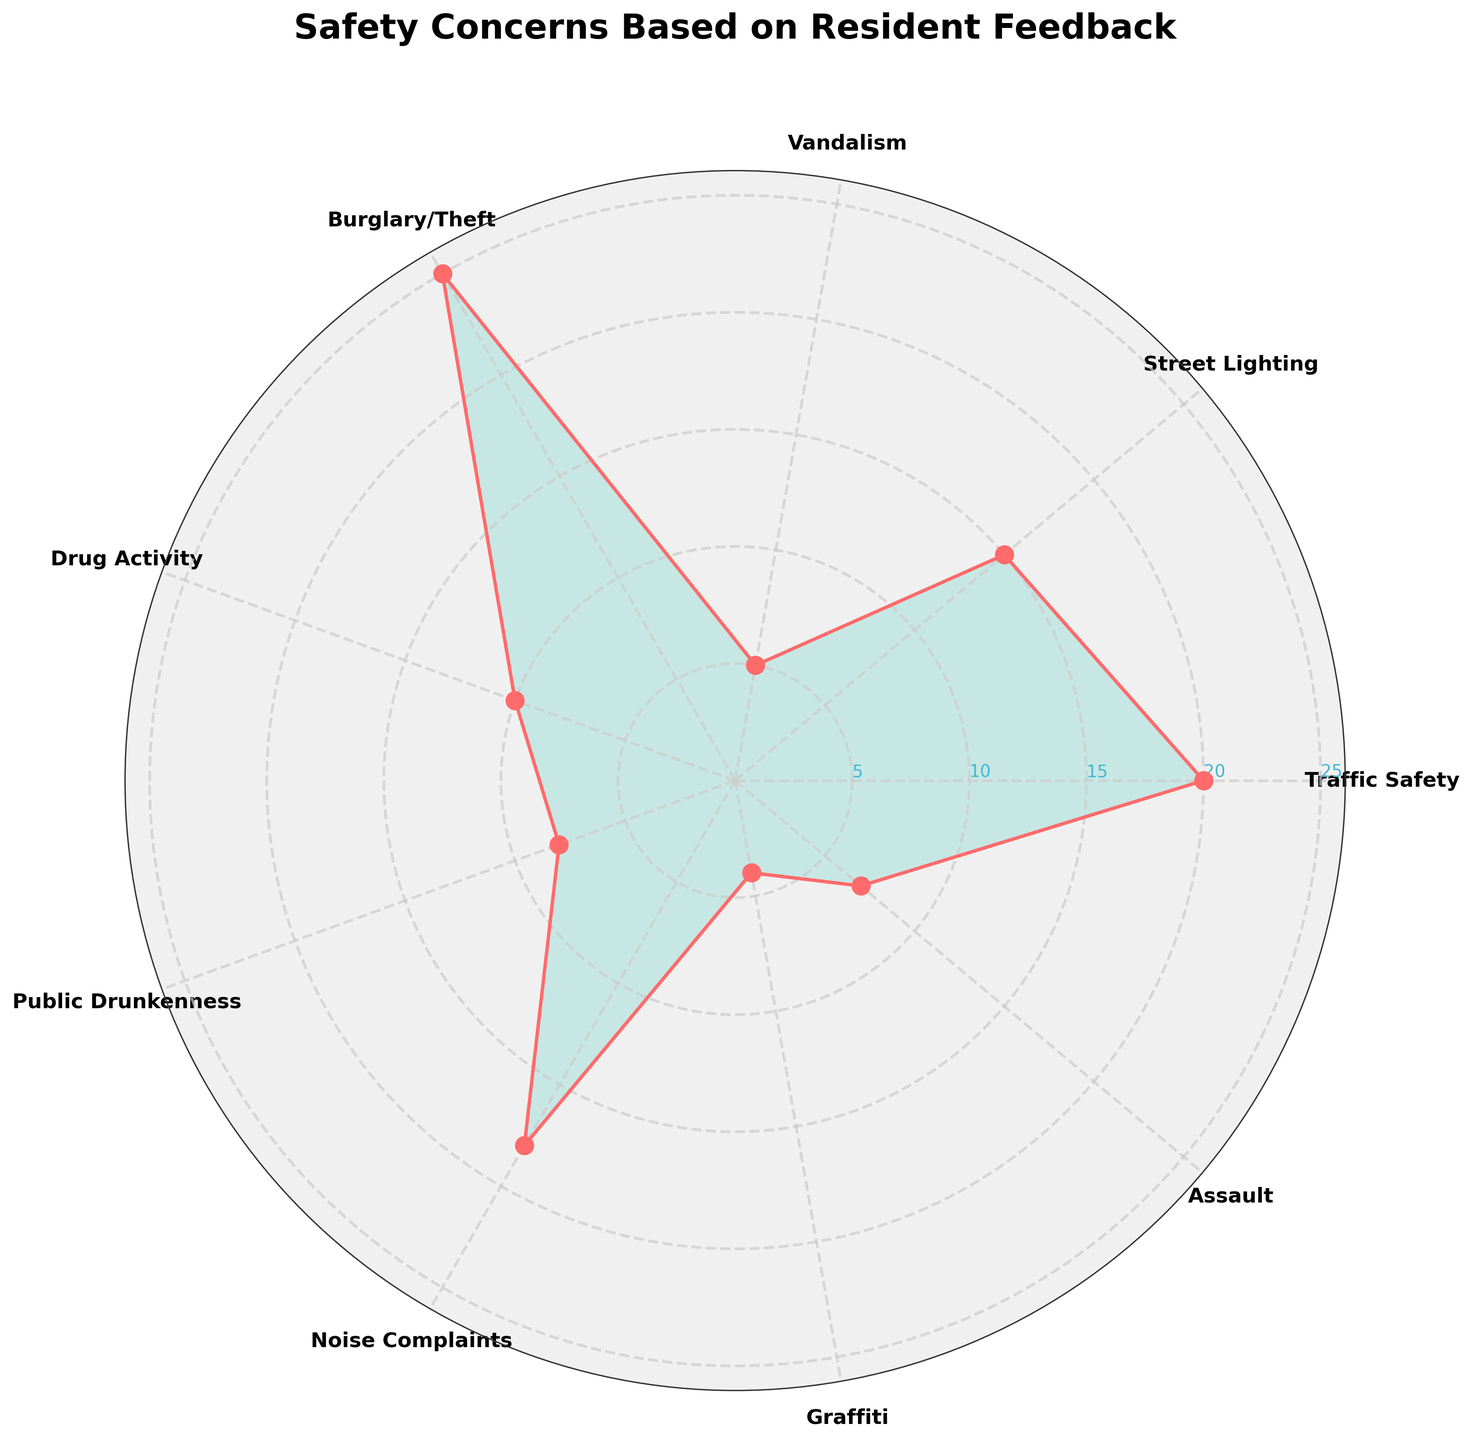What's the title of the chart? The title is usually located at the top of the chart; it gives us an idea of what the chart represents. In this case, the title reads "Safety Concerns Based on Resident Feedback."
Answer: Safety Concerns Based on Resident Feedback What category has the highest value? The highest value is represented by the longest radial line. By inspecting the chart, "Burglary/Theft" has the longest line, indicating it has the highest value.
Answer: Burglary/Theft What is the value of "Noise Complaints"? Find the label "Noise Complaints" and trace the radial axis to its end. The label at the end tells us the value, which is 18.
Answer: 18 How many safety concerns have values greater than 10? Look at which radial lines extend beyond the 10 mark. Categories with values above 10 are "Traffic Safety", "Street Lighting", "Noise Complaints", and "Burglary/Theft", making a total of 4 categories.
Answer: 4 How does "Drug Activity" compare to "Assault"? "Drug Activity" has a value of 10 while "Assault" has a value of 7. Thus, "Drug Activity" has a higher value than "Assault".
Answer: Drug Activity > Assault What is the average value of the listed safety concerns? Sum all the listed values: 20 + 15 + 5 + 25 + 10 + 8 + 18 + 4 + 7 = 112. There are 9 categories, so the average is 112/9 ≈ 12.44
Answer: 12.44 What is the difference in value between "Traffic Safety" and "Vandalism"? The value of "Traffic Safety" is 20 and "Vandalism" is 5. The difference is 20 - 5 = 15.
Answer: 15 Which category has the closest value to "Drug Activity"? "Drug Activity" has a value of 10. The closest value is "Street Lighting" with a value of 15, a difference of 5.
Answer: Street Lighting In terms of safety concerns, which is more common: "Public Drunkenness" or "Assault"? By comparing the radial lengths, "Public Drunkenness" has a value of 8 while "Assault" has 7. Hence, "Public Drunkenness" is more common.
Answer: Public Drunkenness 